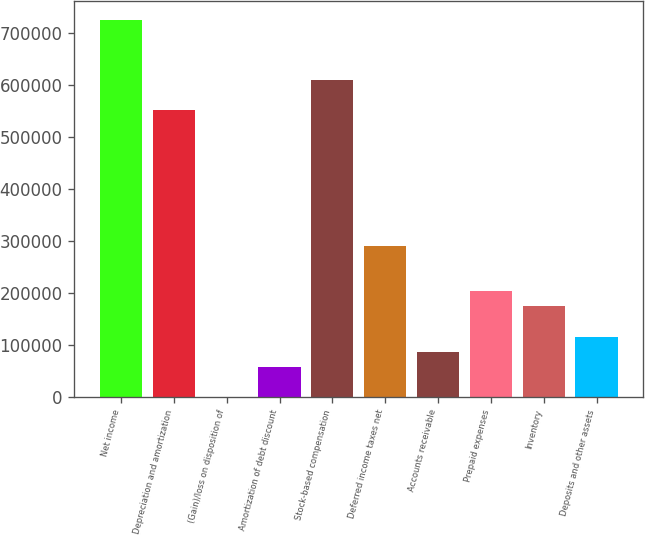Convert chart to OTSL. <chart><loc_0><loc_0><loc_500><loc_500><bar_chart><fcel>Net income<fcel>Depreciation and amortization<fcel>(Gain)/loss on disposition of<fcel>Amortization of debt discount<fcel>Stock-based compensation<fcel>Deferred income taxes net<fcel>Accounts receivable<fcel>Prepaid expenses<fcel>Inventory<fcel>Deposits and other assets<nl><fcel>725834<fcel>551638<fcel>21<fcel>58086<fcel>609704<fcel>290346<fcel>87118.5<fcel>203248<fcel>174216<fcel>116151<nl></chart> 